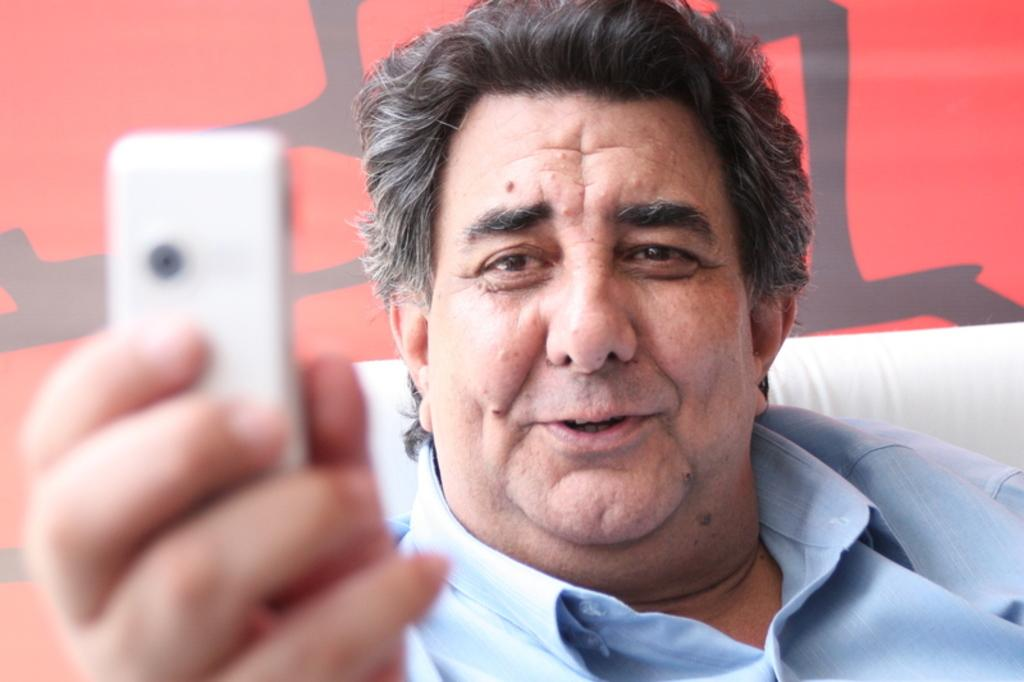Who or what is the main subject in the image? There is a person in the image. What is the person wearing? The person is wearing a blue shirt. What is the person holding in the image? The person is holding a mobile. What can be seen in the background of the image? There is a red wall in the background of the image. Is the person wearing a hat in the image? There is no mention of a hat in the image, so it cannot be determined whether the person is wearing one or not. 